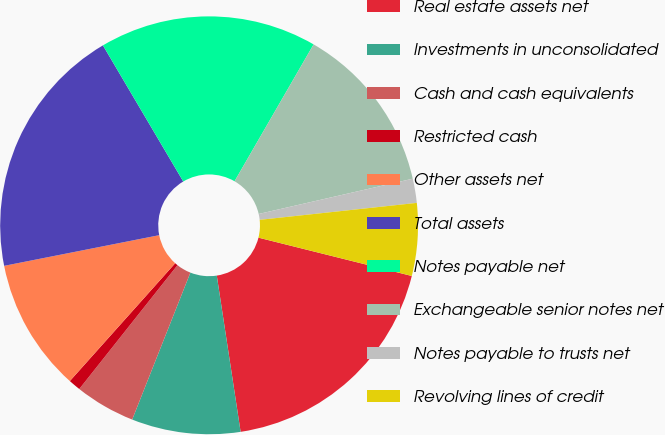Convert chart to OTSL. <chart><loc_0><loc_0><loc_500><loc_500><pie_chart><fcel>Real estate assets net<fcel>Investments in unconsolidated<fcel>Cash and cash equivalents<fcel>Restricted cash<fcel>Other assets net<fcel>Total assets<fcel>Notes payable net<fcel>Exchangeable senior notes net<fcel>Notes payable to trusts net<fcel>Revolving lines of credit<nl><fcel>18.69%<fcel>8.41%<fcel>4.67%<fcel>0.94%<fcel>10.28%<fcel>19.62%<fcel>16.82%<fcel>13.08%<fcel>1.87%<fcel>5.61%<nl></chart> 